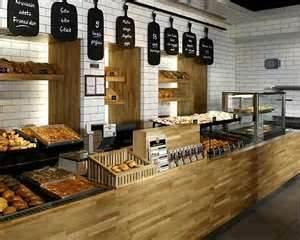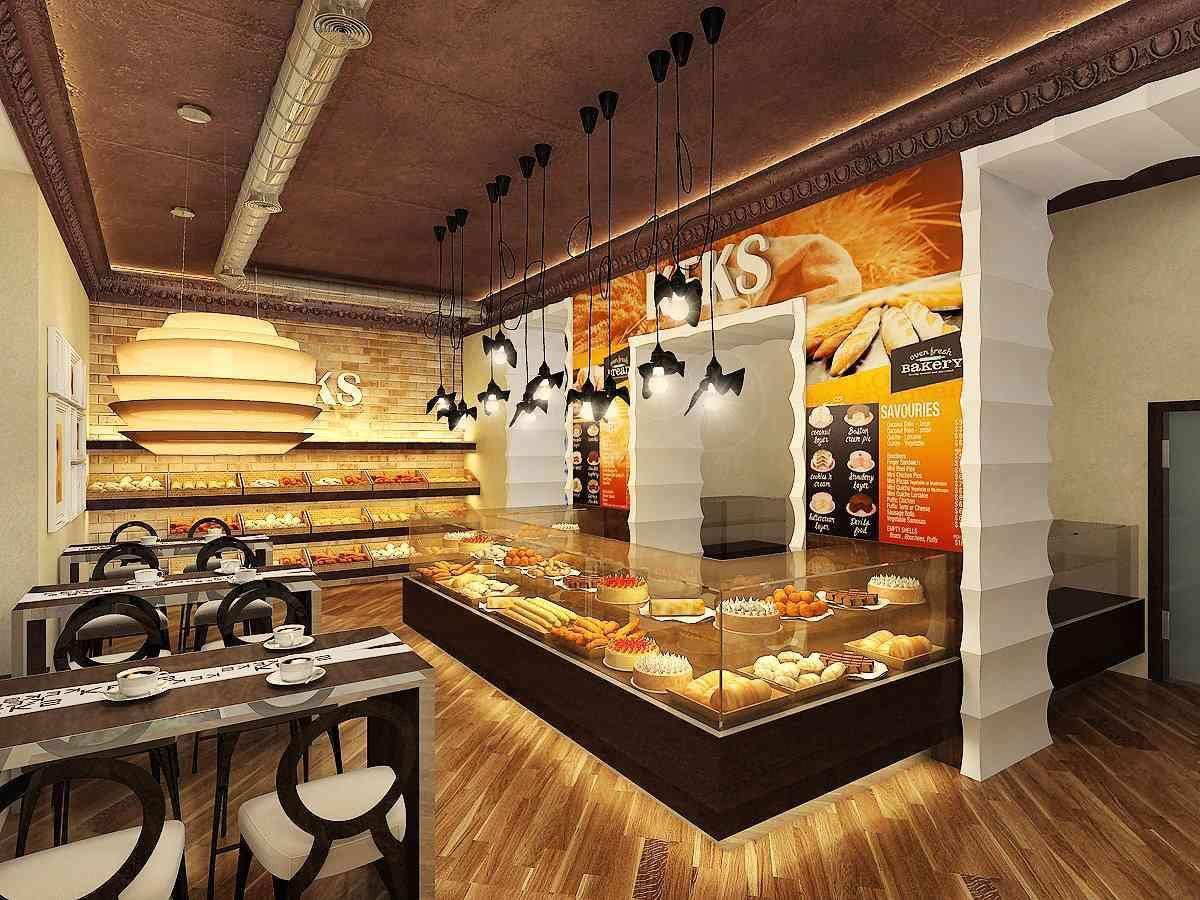The first image is the image on the left, the second image is the image on the right. For the images displayed, is the sentence "The bakery in one image has white tile walls and uses black paddles for signs." factually correct? Answer yes or no. Yes. 